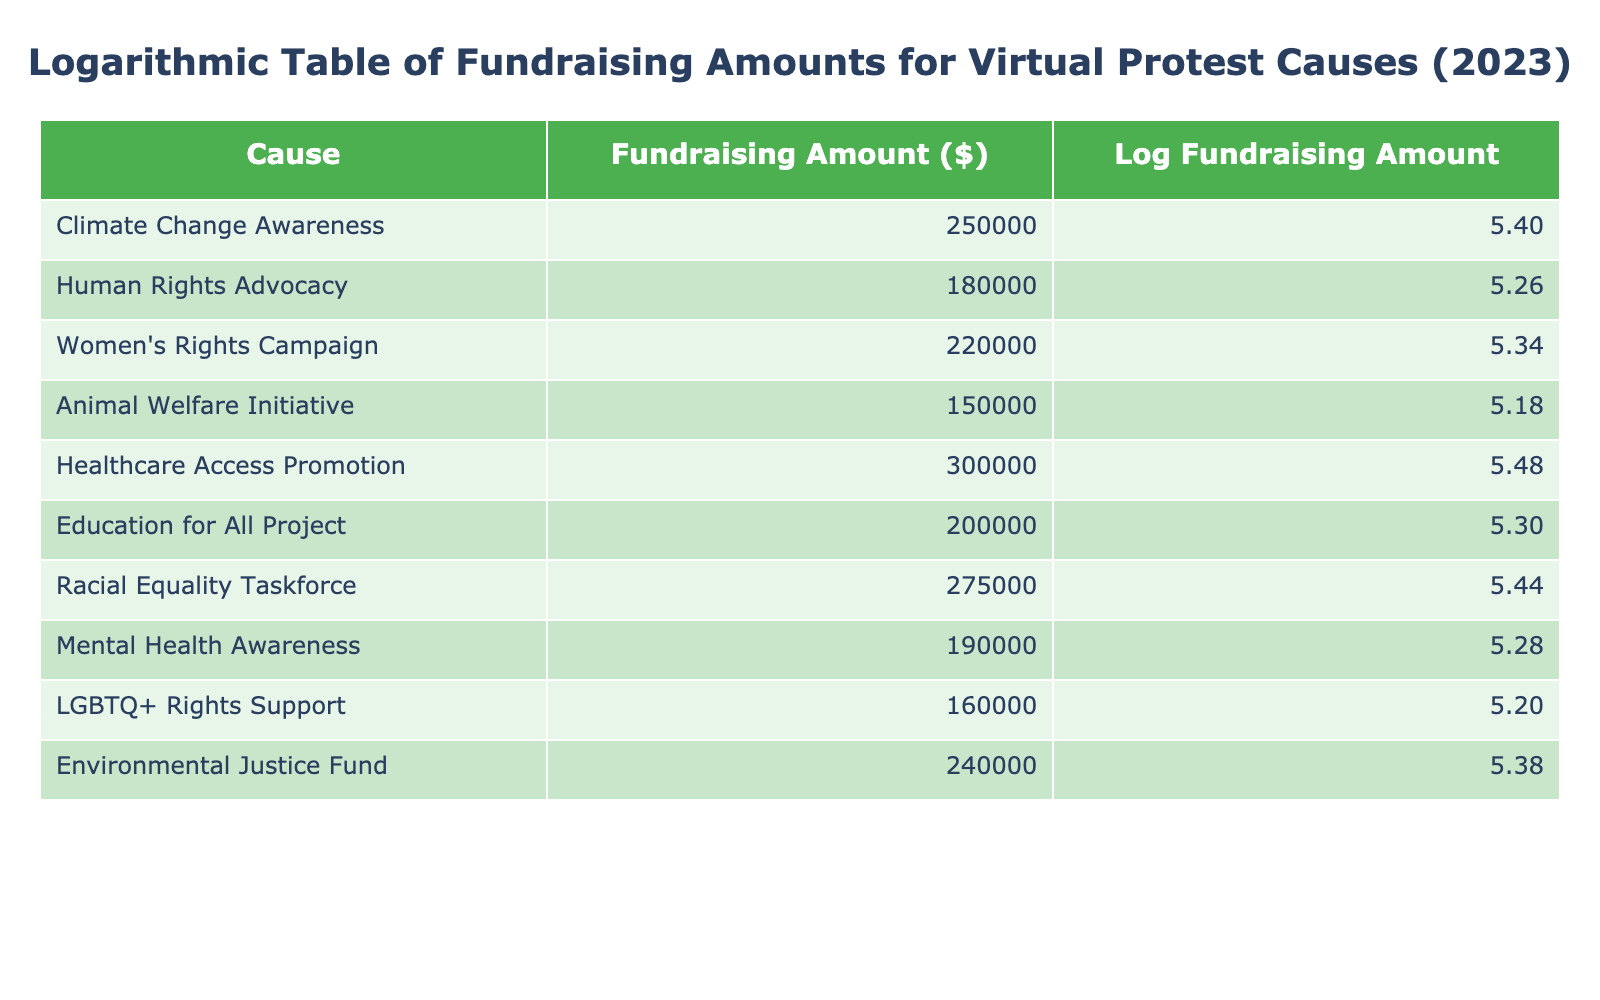What is the highest fundraising amount among the causes? By examining the "Fundraising Amount ($)" column, we see that the highest value is for "Healthcare Access Promotion," which is $300,000.
Answer: $300,000 Which cause received less than $200,000 in fundraising? Looking at the "Fundraising Amount" column, the only cause that received less than $200,000 is "Animal Welfare Initiative," which received $150,000.
Answer: Animal Welfare Initiative What is the total fundraising amount for all causes listed? To find the total, we sum up all the fundraising amounts: 250000 + 180000 + 220000 + 150000 + 300000 + 200000 + 275000 + 190000 + 160000 + 240000 = 1,995,000.
Answer: $1,995,000 Is the fundraising amount for "Women's Rights Campaign" greater than the average fundraising amount of the causes? The average is calculated as the total ($1,995,000) divided by the number of causes (10), which yields $199,500. Since the "Women's Rights Campaign" amount is $220,000, it is greater than the average.
Answer: Yes What is the difference between the highest and lowest fundraising amounts? The highest amount is $300,000 for "Healthcare Access Promotion," and the lowest is $150,000 for "Animal Welfare Initiative." The difference is calculated as $300,000 - $150,000 = $150,000.
Answer: $150,000 How many causes had fundraising amounts greater than $200,000? Checking the table, we find that these causes are "Climate Change Awareness," "Women's Rights Campaign," "Healthcare Access Promotion," "Racial Equality Taskforce," and "Environmental Justice Fund." This totals five causes.
Answer: 5 Which cause has the second highest fundraising amount? From the "Fundraising Amount" column, the highest is $300,000 for "Healthcare Access Promotion," and the second highest is $275,000 for the "Racial Equality Taskforce."
Answer: Racial Equality Taskforce What is the average fundraising amount for all causes? The total fundraising amount is $1,995,000. We have 10 causes, so the average is calculated as $1,995,000 divided by 10, resulting in $199,500.
Answer: $199,500 